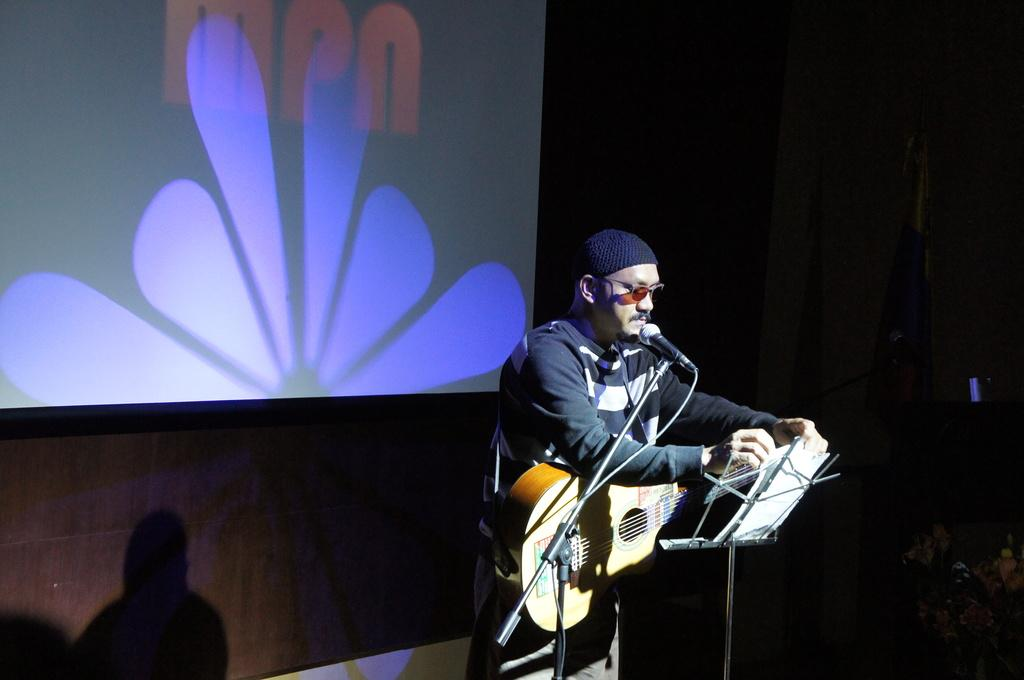What is the man in the image doing? The man is holding a guitar on his shoulders. What object is the man likely to use for singing or speaking? There is a microphone in the image. What might the man be standing near or on? There is a stand in the image. What can be seen behind the man in the image? There is a screen in the image. Can you see a frog jumping in the image? No, there is no frog or jumping activity present in the image. 